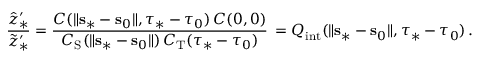Convert formula to latex. <formula><loc_0><loc_0><loc_500><loc_500>\frac { \hat { z } _ { \ast } ^ { \prime } } { \tilde { z } _ { \ast } ^ { \prime } } = \frac { C ( \| { \mathbf s } _ { \ast } - { \mathbf s } _ { 0 } \| , \tau _ { \ast } - \tau _ { 0 } ) \, C ( 0 , 0 ) } { C _ { S } ( \| { \mathbf s } _ { \ast } - { \mathbf s } _ { 0 } \| ) \, C _ { T } ( \tau _ { \ast } - \tau _ { 0 } ) } \, = Q _ { i n t } ( \| { \mathbf s } _ { \ast } - { \mathbf s } _ { 0 } \| , \tau _ { \ast } - \tau _ { 0 } ) \, .</formula> 